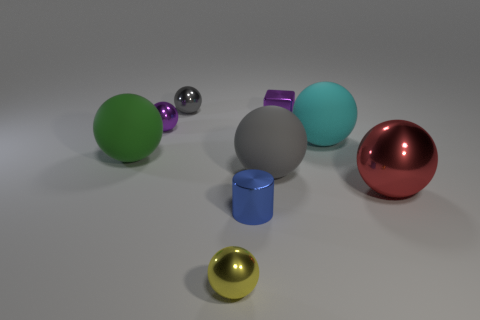What number of other objects are the same material as the large gray sphere?
Offer a terse response. 2. What number of other things are the same color as the shiny cylinder?
Your answer should be very brief. 0. What is the material of the gray sphere in front of the purple thing right of the small purple sphere?
Keep it short and to the point. Rubber. Are any yellow matte spheres visible?
Your response must be concise. No. What size is the metallic sphere left of the metallic ball that is behind the purple metallic sphere?
Provide a succinct answer. Small. Are there more big rubber things behind the green matte thing than big green balls behind the tiny gray metal ball?
Offer a very short reply. Yes. What number of balls are either large cyan matte objects or green things?
Provide a short and direct response. 2. There is a purple metal object that is on the left side of the blue metal thing; is its shape the same as the cyan thing?
Provide a succinct answer. Yes. The small cylinder is what color?
Your answer should be compact. Blue. The big metal object that is the same shape as the gray rubber object is what color?
Provide a succinct answer. Red. 